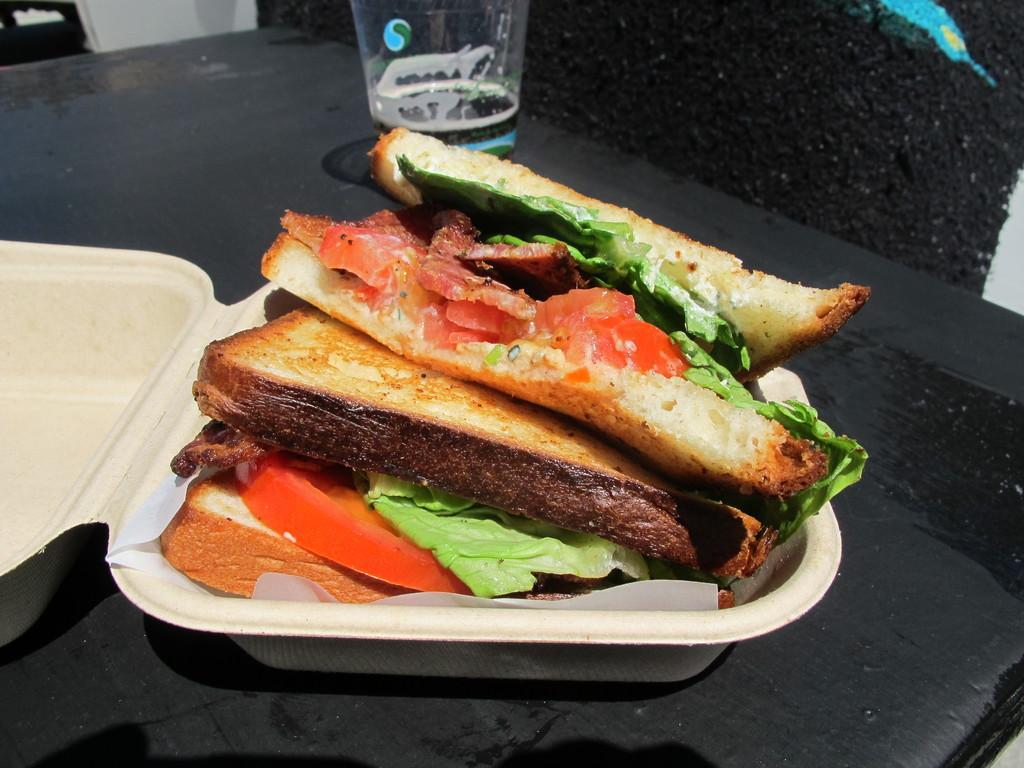Describe this image in one or two sentences. On a black table there are sandwiches in a box and there is a glass. 